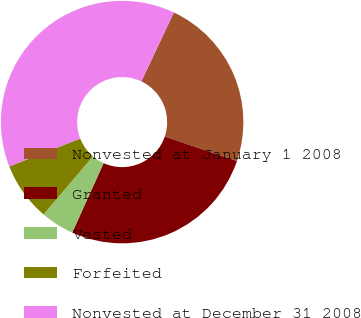<chart> <loc_0><loc_0><loc_500><loc_500><pie_chart><fcel>Nonvested at January 1 2008<fcel>Granted<fcel>Vested<fcel>Forfeited<fcel>Nonvested at December 31 2008<nl><fcel>23.19%<fcel>26.54%<fcel>4.47%<fcel>7.82%<fcel>37.97%<nl></chart> 